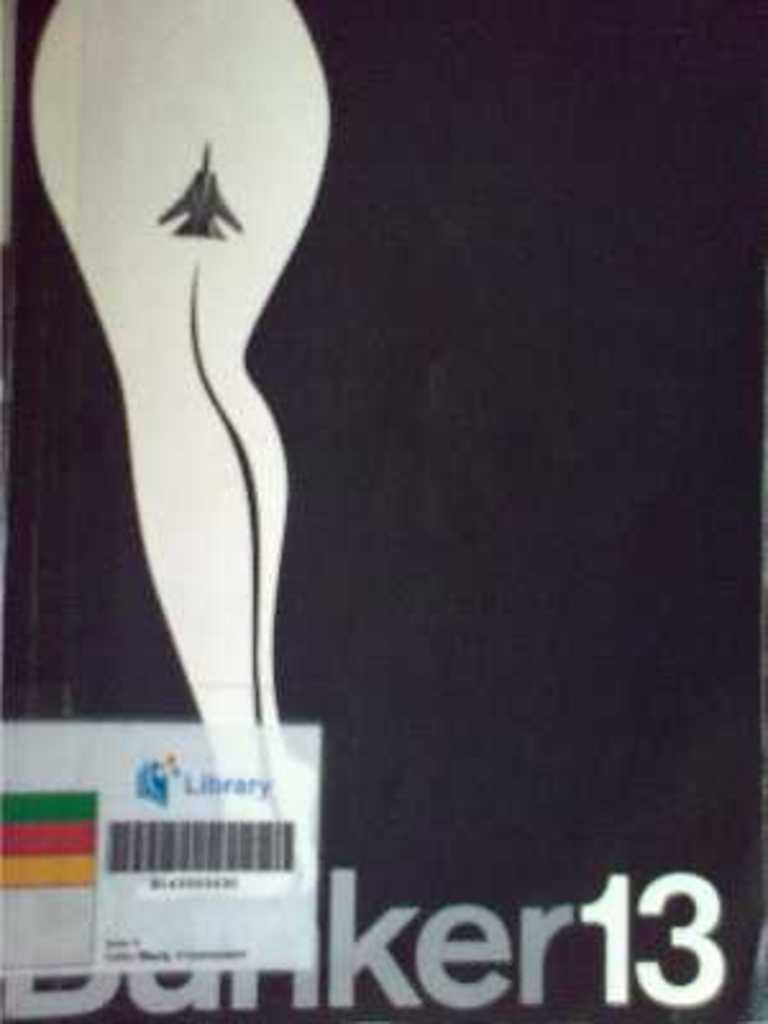<image>
Present a compact description of the photo's key features. A libray tag is on the front cover of a book called Banker13. 